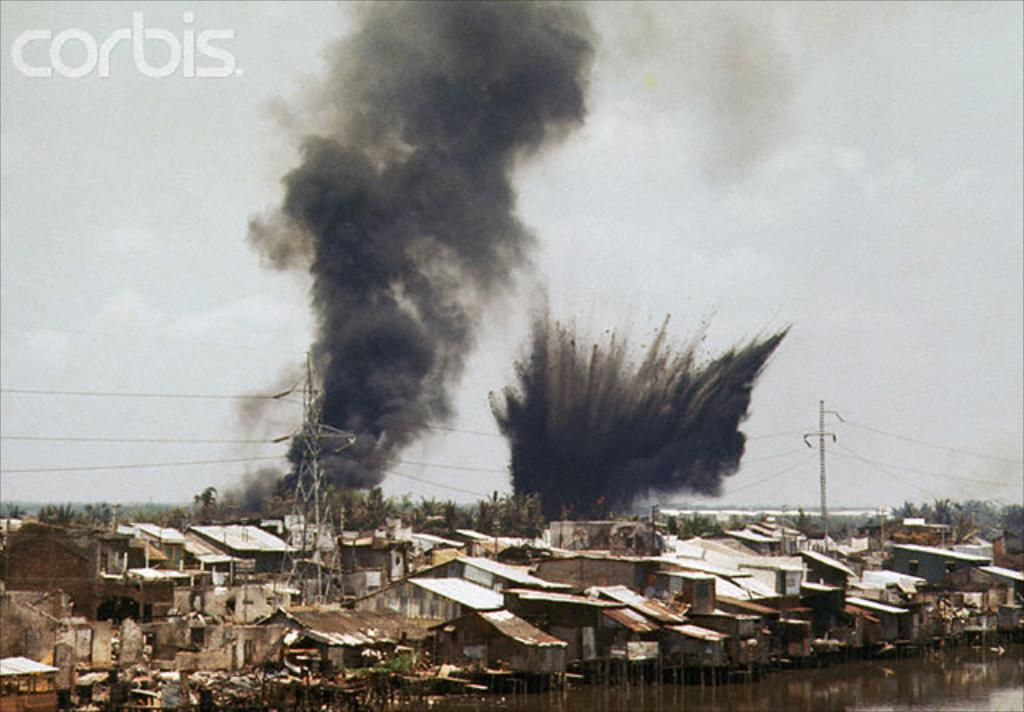What type of structures can be seen in the image? There are houses in the image. What natural elements are present in the image? There are trees and water visible in the image. What is the source of the smoke in the image? The source of the smoke is not specified in the image. What type of infrastructure is present in the image? There are current towers and wires visible in the image. What is the color of the sky in the image? The sky is white in color. Can you tell me how many farmers are shown working in the fields in the image? There are no farmers or fields present in the image. What type of grip does the current tower have on the wires in the image? There is no indication of a grip on the wires in the image; the current towers are simply supporting the wires. 